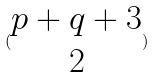<formula> <loc_0><loc_0><loc_500><loc_500>( \begin{matrix} p + q + 3 \\ 2 \end{matrix} )</formula> 